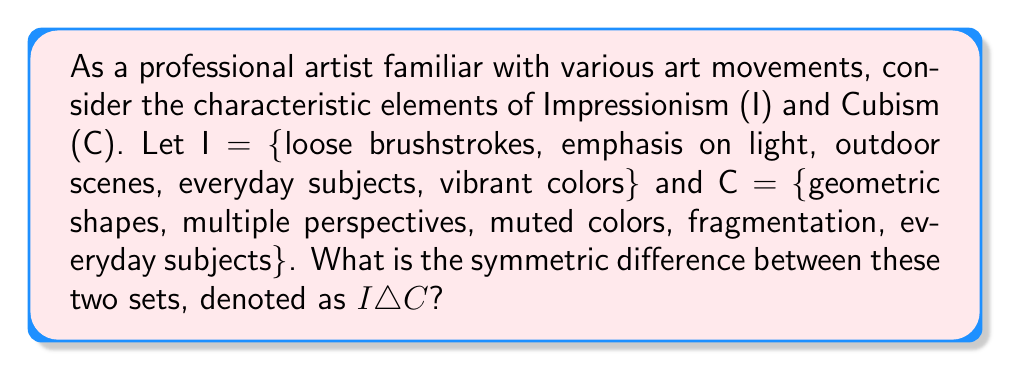Solve this math problem. To solve this problem, we need to understand the concept of symmetric difference in set theory and apply it to the given art movements.

1. The symmetric difference of two sets A and B, denoted as $A \triangle B$, is defined as the set of elements that are in either A or B, but not in both. It can be expressed as:

   $A \triangle B = (A \setminus B) \cup (B \setminus A)$

   where $\setminus$ represents set difference.

2. Let's identify the elements unique to each set:
   
   $I \setminus C$ = {loose brushstrokes, emphasis on light, outdoor scenes, vibrant colors}
   $C \setminus I$ = {geometric shapes, multiple perspectives, muted colors, fragmentation}

3. The symmetric difference is the union of these two sets:

   $I \triangle C = (I \setminus C) \cup (C \setminus I)$

4. Combining the elements from steps 2 and 3:

   $I \triangle C$ = {loose brushstrokes, emphasis on light, outdoor scenes, vibrant colors, geometric shapes, multiple perspectives, muted colors, fragmentation}

Note that "everyday subjects" is present in both sets, so it's not included in the symmetric difference.
Answer: $I \triangle C$ = {loose brushstrokes, emphasis on light, outdoor scenes, vibrant colors, geometric shapes, multiple perspectives, muted colors, fragmentation} 